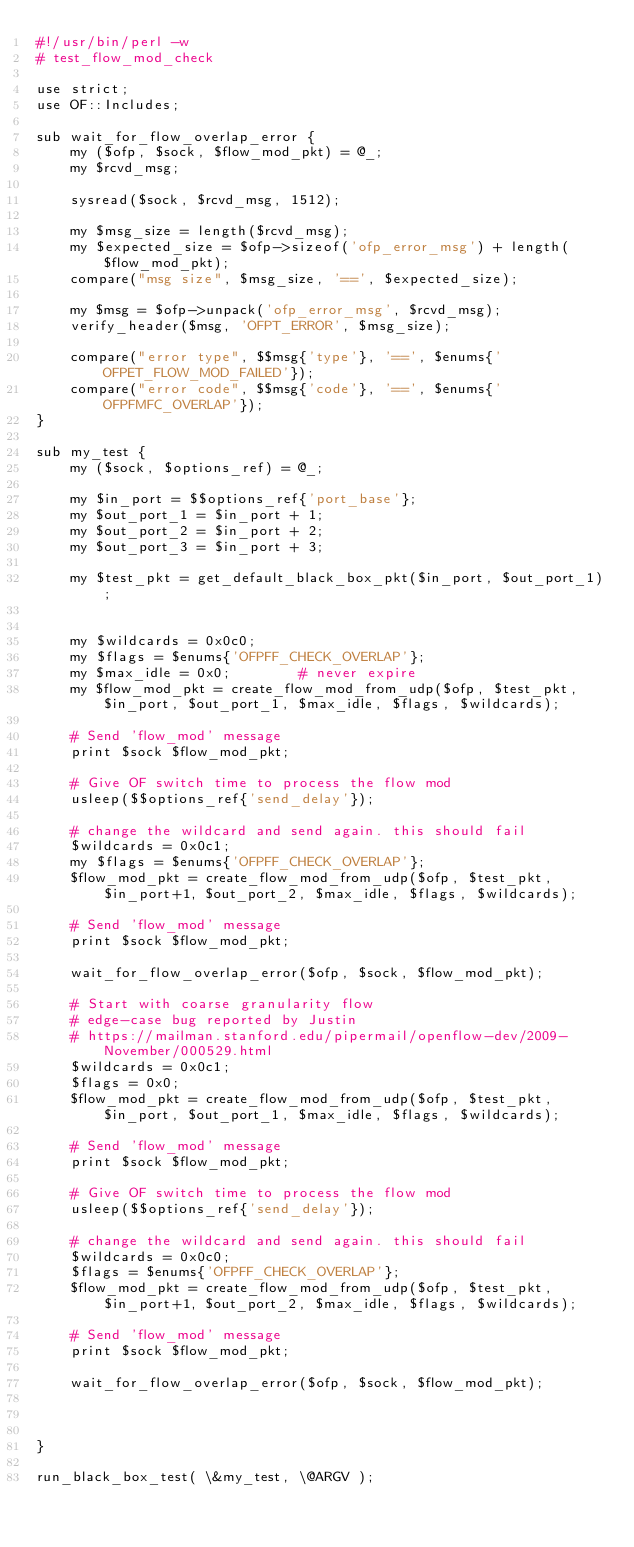<code> <loc_0><loc_0><loc_500><loc_500><_Perl_>#!/usr/bin/perl -w
# test_flow_mod_check

use strict;
use OF::Includes;

sub wait_for_flow_overlap_error {
    my ($ofp, $sock, $flow_mod_pkt) = @_;
    my $rcvd_msg;

    sysread($sock, $rcvd_msg, 1512);

    my $msg_size = length($rcvd_msg);
    my $expected_size = $ofp->sizeof('ofp_error_msg') + length($flow_mod_pkt);
    compare("msg size", $msg_size, '==', $expected_size);

    my $msg = $ofp->unpack('ofp_error_msg', $rcvd_msg);
    verify_header($msg, 'OFPT_ERROR', $msg_size);

    compare("error type", $$msg{'type'}, '==', $enums{'OFPET_FLOW_MOD_FAILED'});
    compare("error code", $$msg{'code'}, '==', $enums{'OFPFMFC_OVERLAP'});
}

sub my_test {
    my ($sock, $options_ref) = @_;

    my $in_port = $$options_ref{'port_base'};
    my $out_port_1 = $in_port + 1;
    my $out_port_2 = $in_port + 2;
    my $out_port_3 = $in_port + 3;

    my $test_pkt = get_default_black_box_pkt($in_port, $out_port_1);


    my $wildcards = 0x0c0;
    my $flags = $enums{'OFPFF_CHECK_OVERLAP'};
    my $max_idle = 0x0;        # never expire
    my $flow_mod_pkt = create_flow_mod_from_udp($ofp, $test_pkt, $in_port, $out_port_1, $max_idle, $flags, $wildcards);

    # Send 'flow_mod' message
    print $sock $flow_mod_pkt;

    # Give OF switch time to process the flow mod
    usleep($$options_ref{'send_delay'});

    # change the wildcard and send again. this should fail
    $wildcards = 0x0c1;
    my $flags = $enums{'OFPFF_CHECK_OVERLAP'};
    $flow_mod_pkt = create_flow_mod_from_udp($ofp, $test_pkt, $in_port+1, $out_port_2, $max_idle, $flags, $wildcards);

    # Send 'flow_mod' message
    print $sock $flow_mod_pkt;

    wait_for_flow_overlap_error($ofp, $sock, $flow_mod_pkt);

    # Start with coarse granularity flow
    # edge-case bug reported by Justin
    # https://mailman.stanford.edu/pipermail/openflow-dev/2009-November/000529.html
    $wildcards = 0x0c1;
    $flags = 0x0;
    $flow_mod_pkt = create_flow_mod_from_udp($ofp, $test_pkt, $in_port, $out_port_1, $max_idle, $flags, $wildcards);

    # Send 'flow_mod' message
    print $sock $flow_mod_pkt;

    # Give OF switch time to process the flow mod
    usleep($$options_ref{'send_delay'});

    # change the wildcard and send again. this should fail
    $wildcards = 0x0c0;
    $flags = $enums{'OFPFF_CHECK_OVERLAP'};
    $flow_mod_pkt = create_flow_mod_from_udp($ofp, $test_pkt, $in_port+1, $out_port_2, $max_idle, $flags, $wildcards);

    # Send 'flow_mod' message
    print $sock $flow_mod_pkt;

    wait_for_flow_overlap_error($ofp, $sock, $flow_mod_pkt);



}

run_black_box_test( \&my_test, \@ARGV );
</code> 